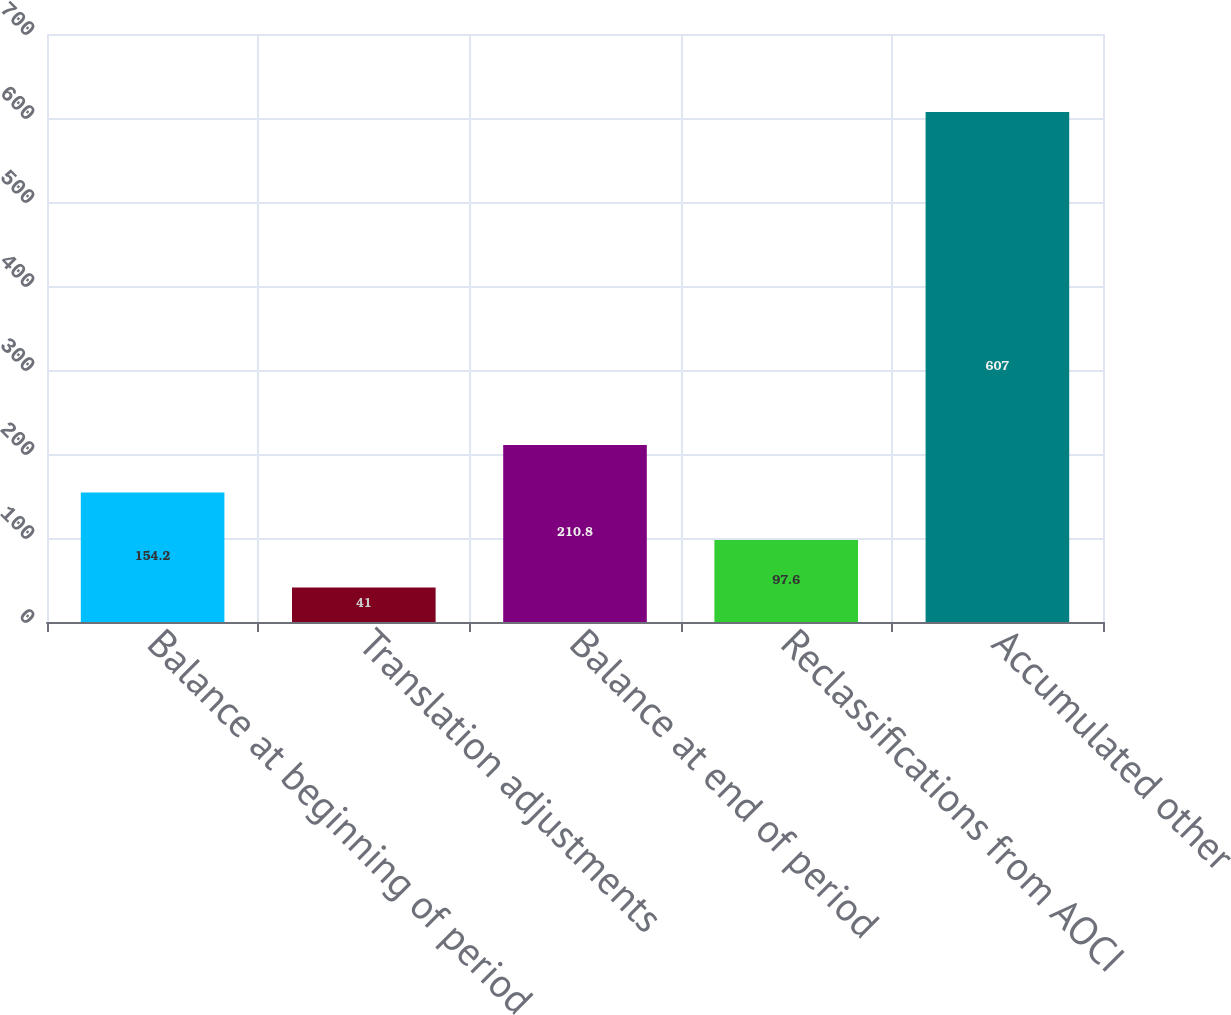Convert chart to OTSL. <chart><loc_0><loc_0><loc_500><loc_500><bar_chart><fcel>Balance at beginning of period<fcel>Translation adjustments<fcel>Balance at end of period<fcel>Reclassifications from AOCI<fcel>Accumulated other<nl><fcel>154.2<fcel>41<fcel>210.8<fcel>97.6<fcel>607<nl></chart> 